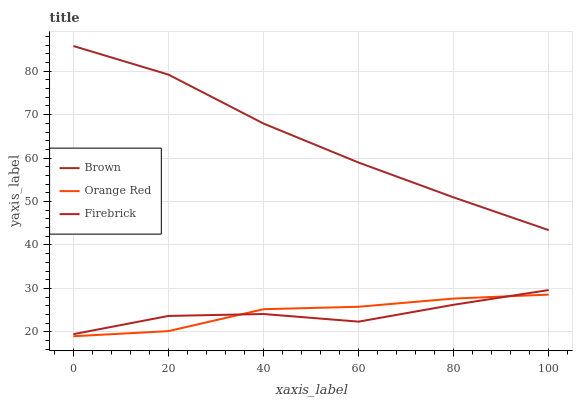Does Firebrick have the minimum area under the curve?
Answer yes or no. Yes. Does Brown have the maximum area under the curve?
Answer yes or no. Yes. Does Orange Red have the minimum area under the curve?
Answer yes or no. No. Does Orange Red have the maximum area under the curve?
Answer yes or no. No. Is Brown the smoothest?
Answer yes or no. Yes. Is Firebrick the roughest?
Answer yes or no. Yes. Is Orange Red the smoothest?
Answer yes or no. No. Is Orange Red the roughest?
Answer yes or no. No. Does Orange Red have the lowest value?
Answer yes or no. Yes. Does Firebrick have the lowest value?
Answer yes or no. No. Does Brown have the highest value?
Answer yes or no. Yes. Does Firebrick have the highest value?
Answer yes or no. No. Is Firebrick less than Brown?
Answer yes or no. Yes. Is Brown greater than Firebrick?
Answer yes or no. Yes. Does Orange Red intersect Firebrick?
Answer yes or no. Yes. Is Orange Red less than Firebrick?
Answer yes or no. No. Is Orange Red greater than Firebrick?
Answer yes or no. No. Does Firebrick intersect Brown?
Answer yes or no. No. 